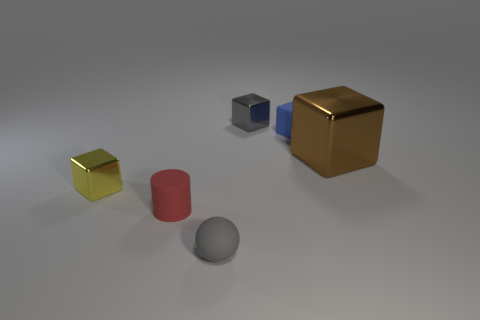Subtract all small gray blocks. How many blocks are left? 3 Subtract all blue blocks. How many blocks are left? 3 Add 4 big metallic cubes. How many objects exist? 10 Subtract 2 blocks. How many blocks are left? 2 Subtract all cubes. How many objects are left? 2 Subtract all purple cubes. Subtract all gray cylinders. How many cubes are left? 4 Subtract all large brown balls. Subtract all tiny matte objects. How many objects are left? 3 Add 5 yellow cubes. How many yellow cubes are left? 6 Add 1 tiny gray metal things. How many tiny gray metal things exist? 2 Subtract 0 cyan cylinders. How many objects are left? 6 